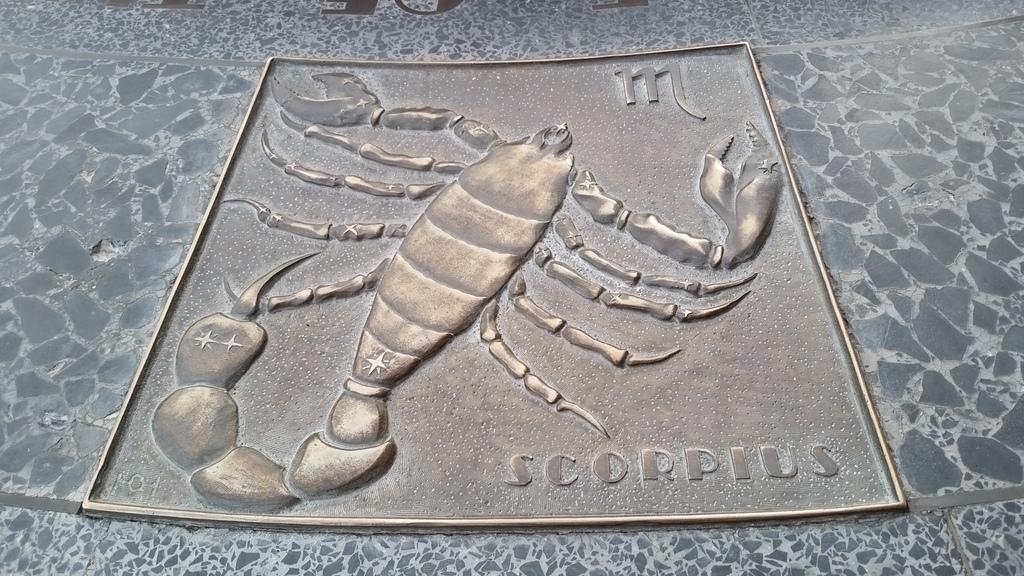In one or two sentences, can you explain what this image depicts? In this image I can see the scorpion on the iron material and it is on the surface. 